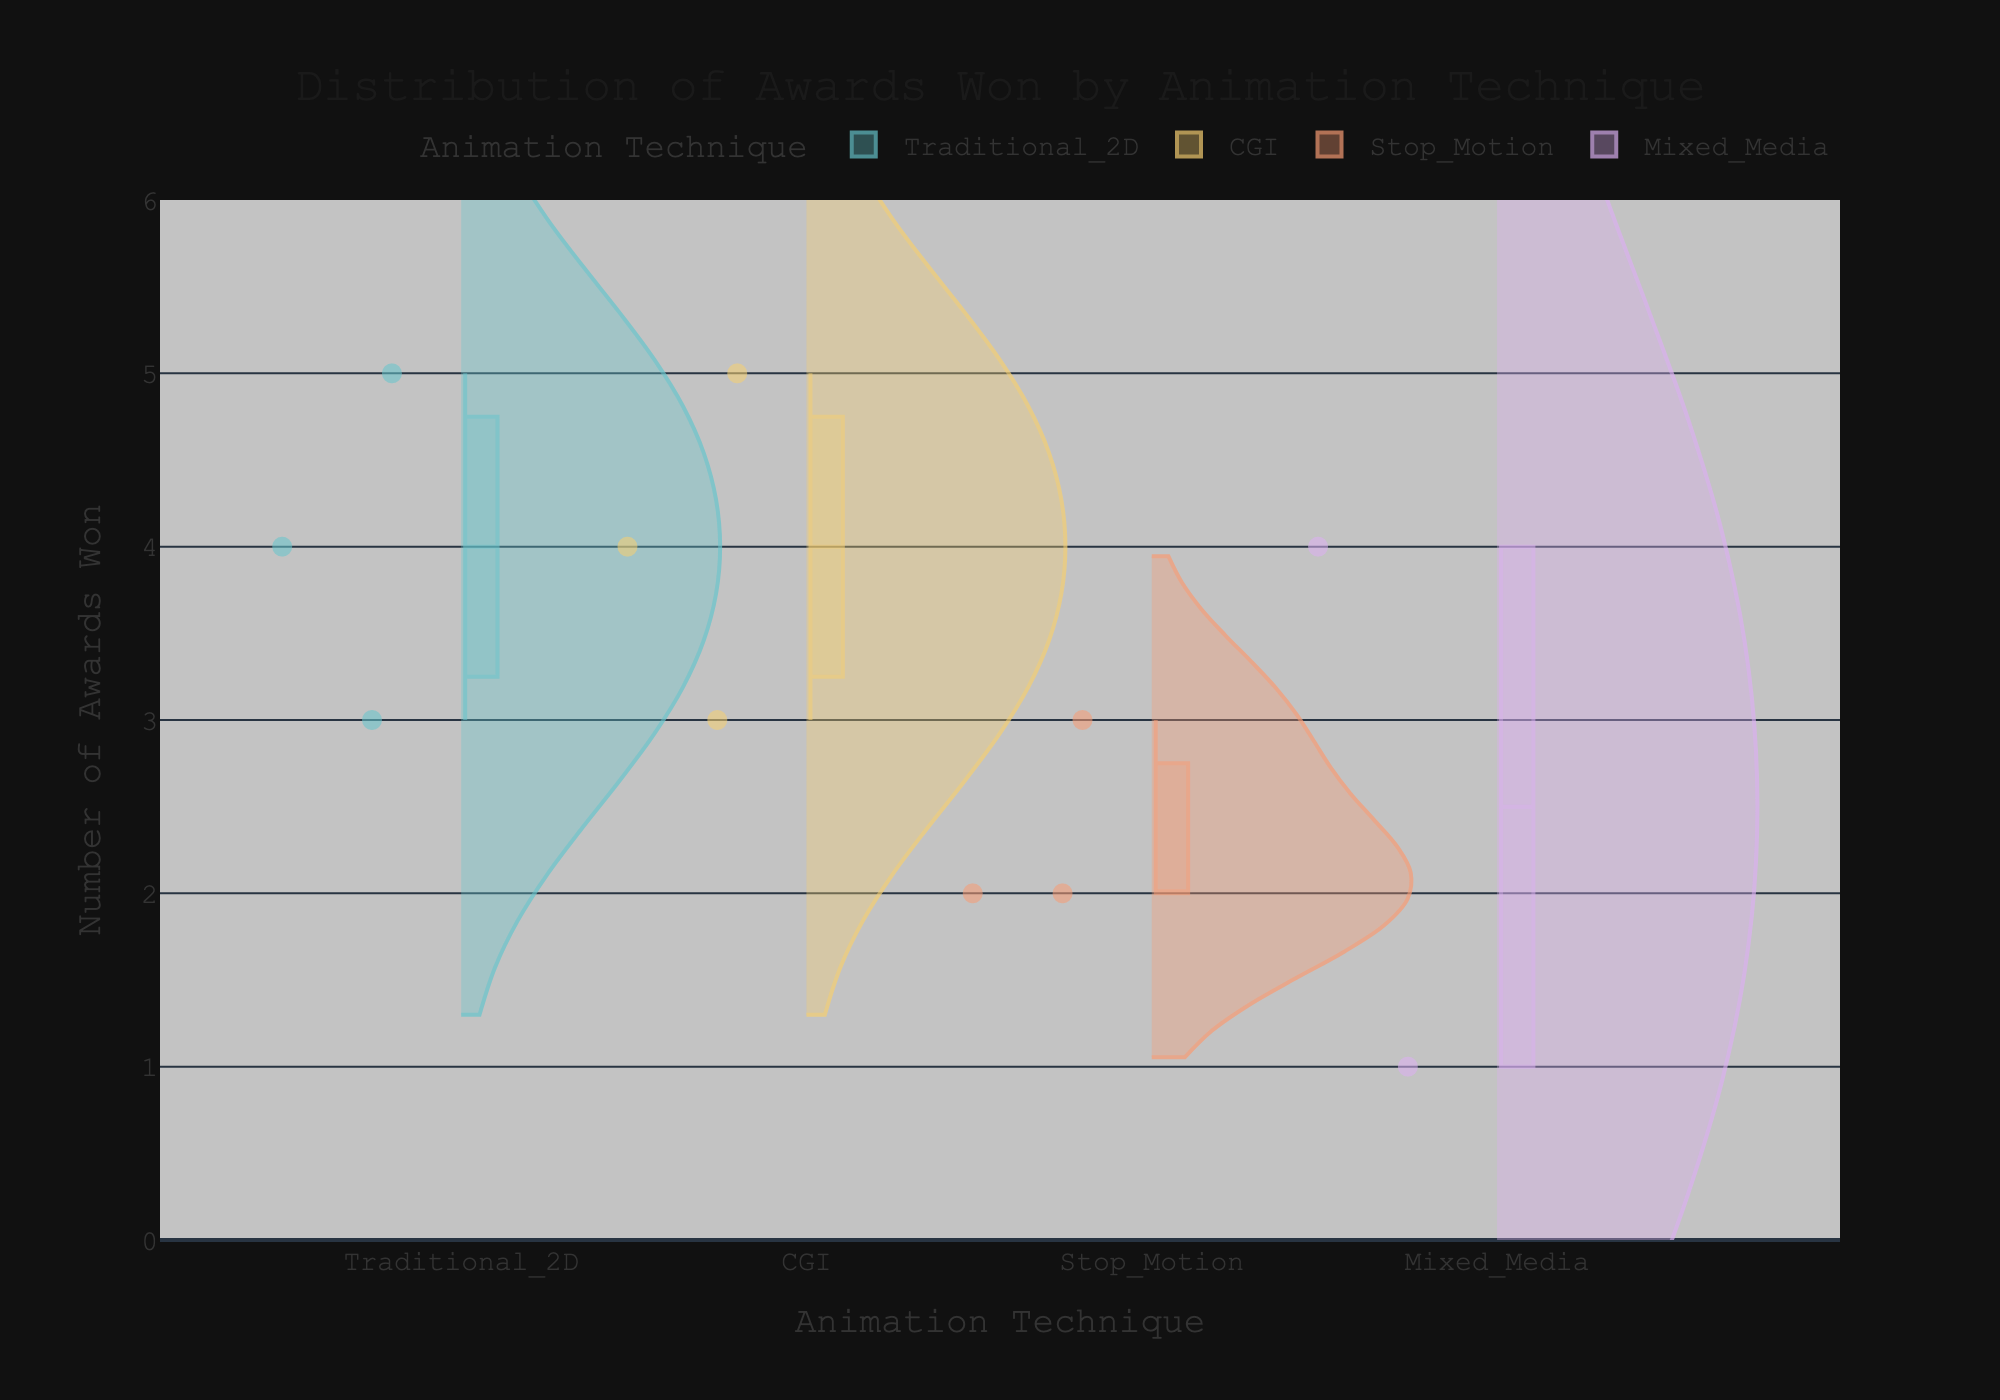What is the title of the figure? The title of the figure is usually displayed prominently at the top of the chart.
Answer: Distribution of Awards Won by Animation Technique Which animation technique has the widest distribution of awards won? Observe the width of the violins; the widest distribution will span the most space along the y-axis.
Answer: Traditional_2D What is the median number of awards won for CGI films? Look for the line inside the box plot in the violin for CGI; this represents the median.
Answer: 4 How many awards did "The Lion King" win and what technique was used? Using the hover data, find "The Lion King" and check the Awards_Won and Animation_Technique values.
Answer: 4, Traditional_2D Which film has the least number of awards and what technique was used? Identify the smallest value on the y-axis and find the corresponding film using the hover data.
Answer: Enchanted, Mixed_Media What's the interquartile range (IQR) of awards won for Traditional_2D animation? The IQR is calculated by subtracting the lower quartile (25th percentile) from the upper quartile (75th percentile), which are represented by the box in the violin plot for Traditional_2D.
Answer: 3.5 - 3 = 0.5 Compare the average awards won between Stop_Motion and Mixed_Media films. Which is higher? Analyze the positions of the points in the respective violins and estimate the average positions.
Answer: Stop_Motion Which animation techniques have films with the highest and lowest number of awards? Find the top and bottom points of all violins, checking the corresponding Animation_Technique.
Answer: Traditional_2D and Mixed_Media What is the range of awards won by films using stop-motion technique? Identify the highest and lowest points in the Stop_Motion violin and calculate the range by subtracting the smallest from the largest value.
Answer: 3 - 2 = 1 How many animation techniques are depicted in the figure? Count the unique categories along the x-axis.
Answer: 4 